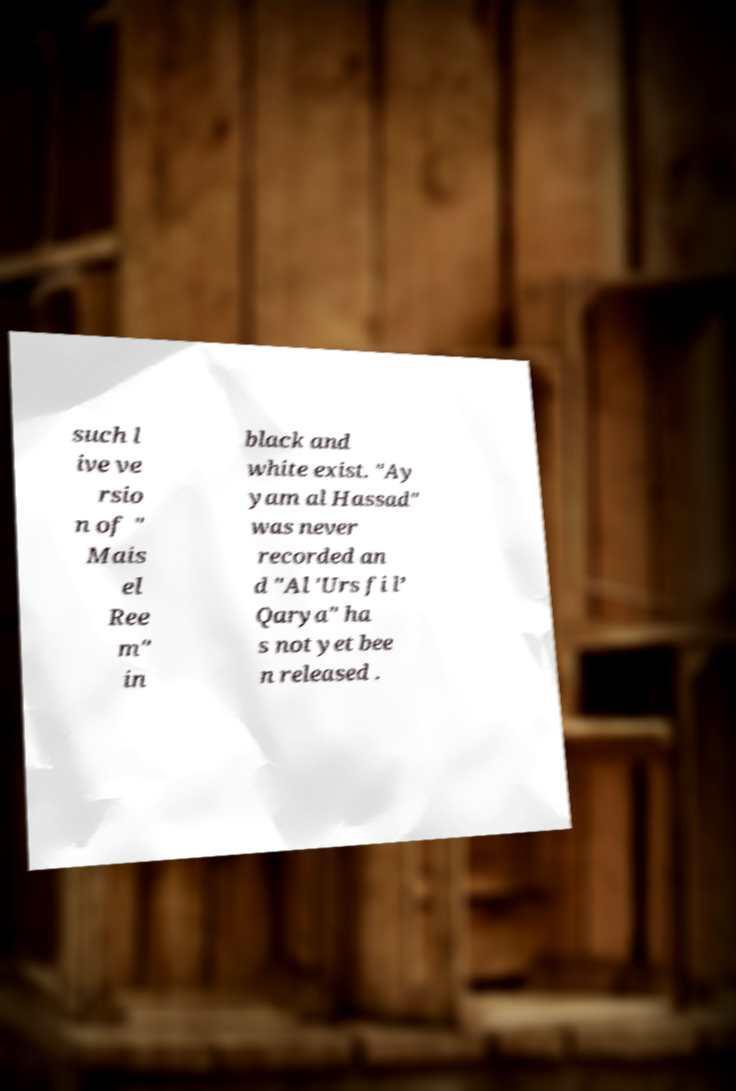Please identify and transcribe the text found in this image. such l ive ve rsio n of " Mais el Ree m" in black and white exist. "Ay yam al Hassad" was never recorded an d "Al 'Urs fi l’ Qarya" ha s not yet bee n released . 